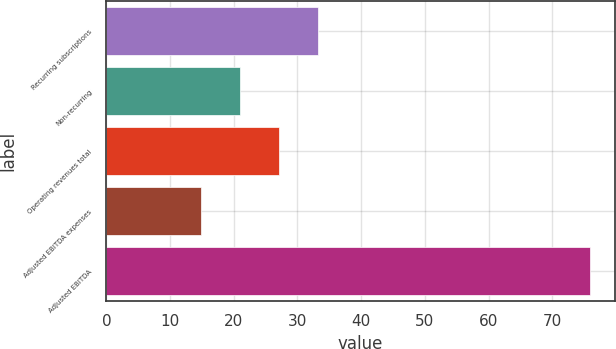<chart> <loc_0><loc_0><loc_500><loc_500><bar_chart><fcel>Recurring subscriptions<fcel>Non-recurring<fcel>Operating revenues total<fcel>Adjusted EBITDA expenses<fcel>Adjusted EBITDA<nl><fcel>33.16<fcel>20.92<fcel>27.04<fcel>14.8<fcel>76<nl></chart> 